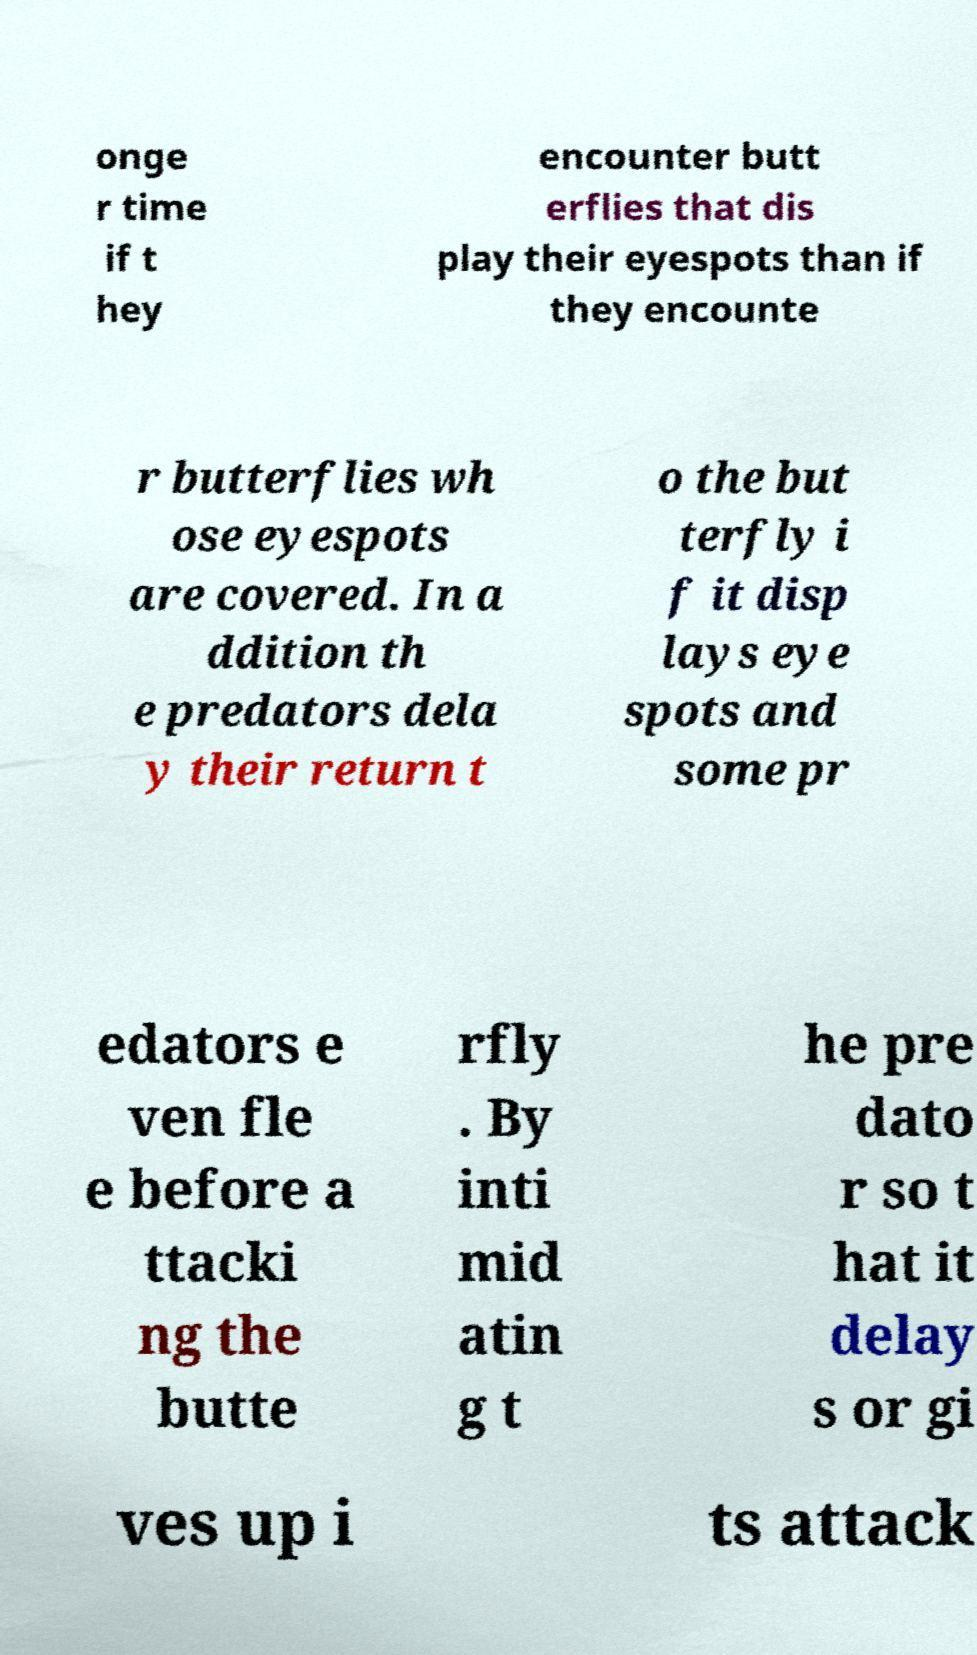Can you accurately transcribe the text from the provided image for me? onge r time if t hey encounter butt erflies that dis play their eyespots than if they encounte r butterflies wh ose eyespots are covered. In a ddition th e predators dela y their return t o the but terfly i f it disp lays eye spots and some pr edators e ven fle e before a ttacki ng the butte rfly . By inti mid atin g t he pre dato r so t hat it delay s or gi ves up i ts attack 